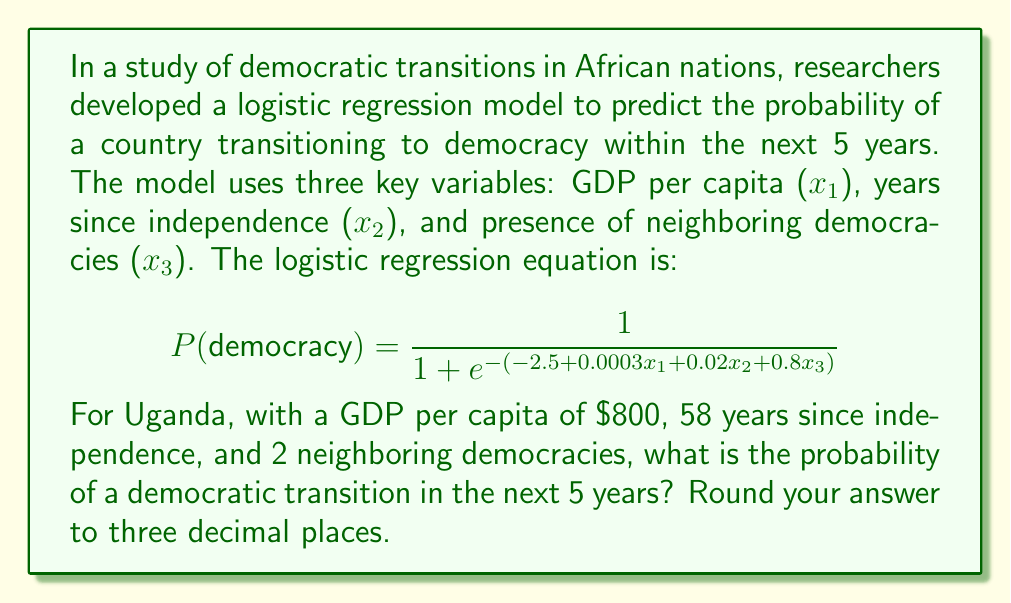Show me your answer to this math problem. To solve this problem, we need to follow these steps:

1. Identify the values for each variable:
   $x_1 = 800$ (GDP per capita)
   $x_2 = 58$ (years since independence)
   $x_3 = 2$ (neighboring democracies)

2. Substitute these values into the logistic regression equation:

$$ P(democracy) = \frac{1}{1 + e^{-(-2.5 + 0.0003(800) + 0.02(58) + 0.8(2))}} $$

3. Calculate the exponent:
   $-2.5 + 0.0003(800) + 0.02(58) + 0.8(2)$
   $= -2.5 + 0.24 + 1.16 + 1.6$
   $= 0.5$

4. Simplify the equation:

$$ P(democracy) = \frac{1}{1 + e^{-0.5}} $$

5. Calculate $e^{-0.5}$:
   $e^{-0.5} \approx 0.6065$

6. Substitute this value and solve:

$$ P(democracy) = \frac{1}{1 + 0.6065} = \frac{1}{1.6065} \approx 0.6225 $$

7. Round to three decimal places:
   0.623

This result indicates a 62.3% probability of Uganda transitioning to democracy within the next 5 years, according to the model.
Answer: 0.623 